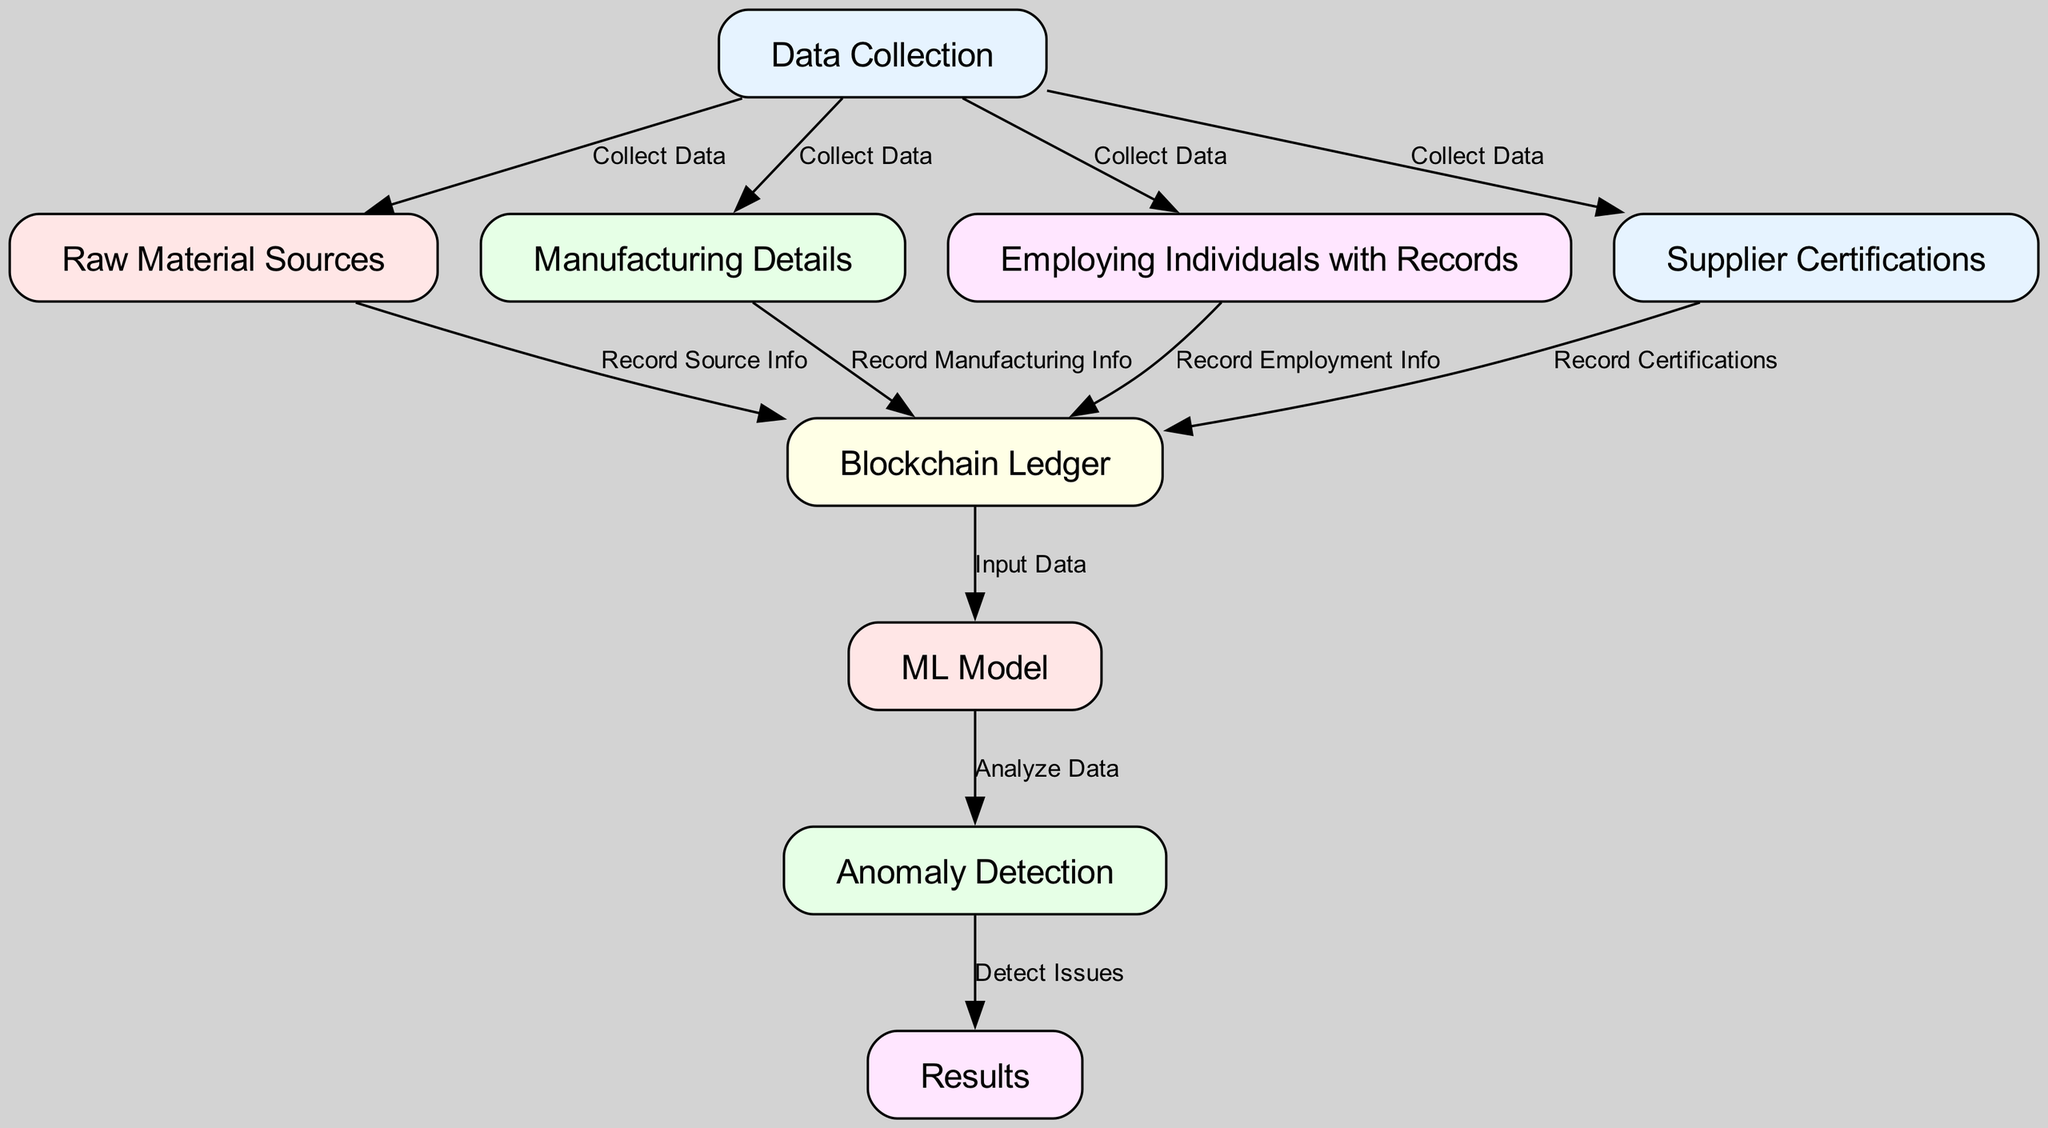What is the starting point of the diagram? The starting point of the diagram is the "Data Collection" node, which collects various sets of data required for the supply chain analysis.
Answer: Data Collection How many nodes are in the diagram? By counting each unique entity represented in the diagram, there are a total of 8 nodes including the Data Collection and Results nodes.
Answer: 8 Which node is directly connected to "Supplier Certifications"? The "Supplier Certifications" node is directly connected to the "Blockchain Ledger" node, indicating that the certifications are recorded there.
Answer: Blockchain Ledger What type of information is recorded in the "Blockchain Ledger" from "Raw Material Sources"? The "Blockchain Ledger" records source information from the "Raw Material Sources," which details the origins of the materials.
Answer: Source Info What is the relationship between the "ML Model" and "Anomaly Detection"? The "ML Model" analyzes the data and subsequently sends the analysis to "Anomaly Detection," which is responsible for identifying any issues.
Answer: Analyze Data How many edges connect to the "Blockchain Ledger"? The "Blockchain Ledger" has four edges connecting it to various nodes: raw material sources, manufacturing details, employing individuals with records, and supplier certifications.
Answer: 4 Which node information leads to "Results"? The information derived from the "Anomaly Detection" node leads to the "Results" node as it detects any issues relevant to the data analyzed.
Answer: Anomaly Detection What does the "Employing Individuals with Records" node contribute to the blockchain? The "Employing Individuals with Records" node contributes employment information that is recorded in the blockchain for transparency in the supply chain.
Answer: Employment Info 